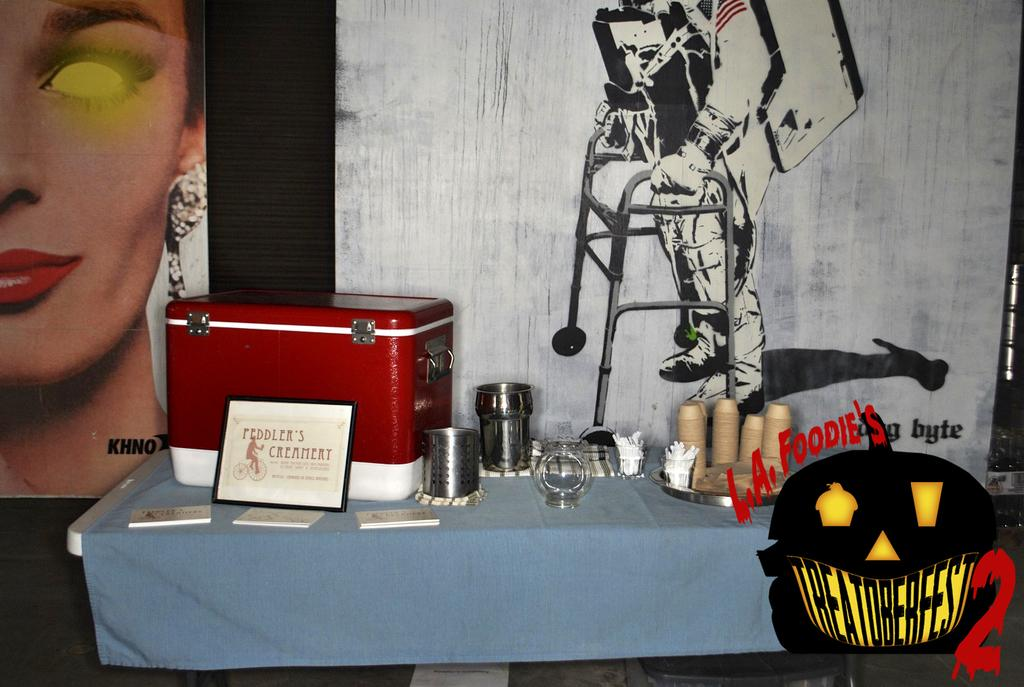<image>
Present a compact description of the photo's key features. Disposable cutlery, a red cooler, and business cards are sitting on a table at the Treatoberfest 2 event. 